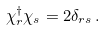<formula> <loc_0><loc_0><loc_500><loc_500>\chi ^ { \dag } _ { r } \chi _ { s } = 2 \delta _ { r s } \, .</formula> 